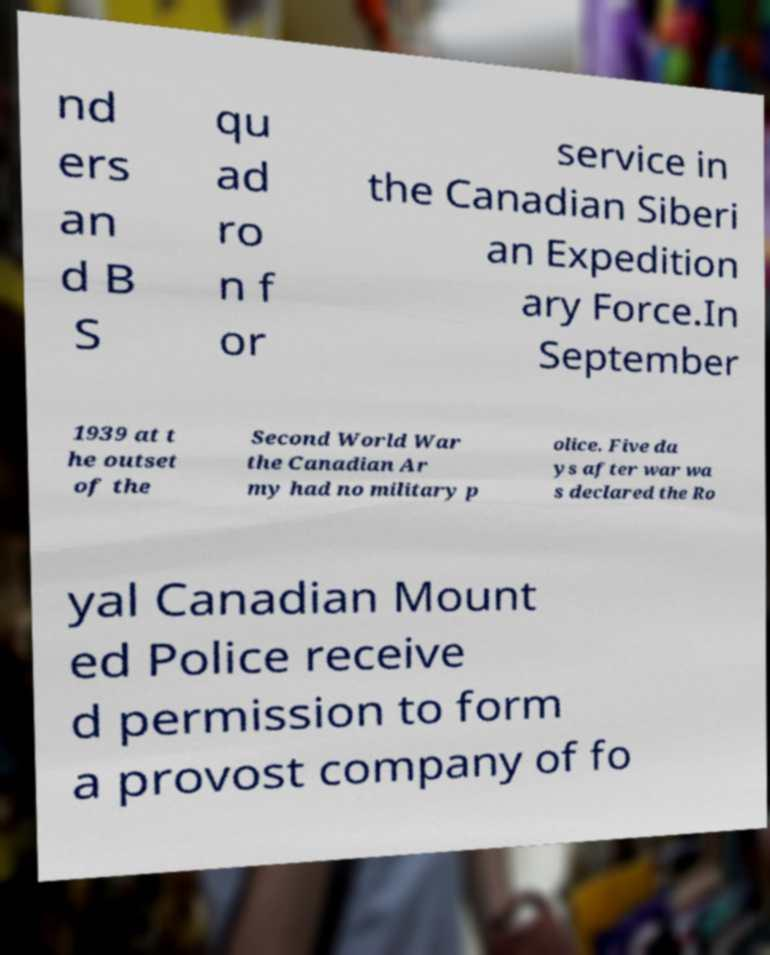What messages or text are displayed in this image? I need them in a readable, typed format. nd ers an d B S qu ad ro n f or service in the Canadian Siberi an Expedition ary Force.In September 1939 at t he outset of the Second World War the Canadian Ar my had no military p olice. Five da ys after war wa s declared the Ro yal Canadian Mount ed Police receive d permission to form a provost company of fo 